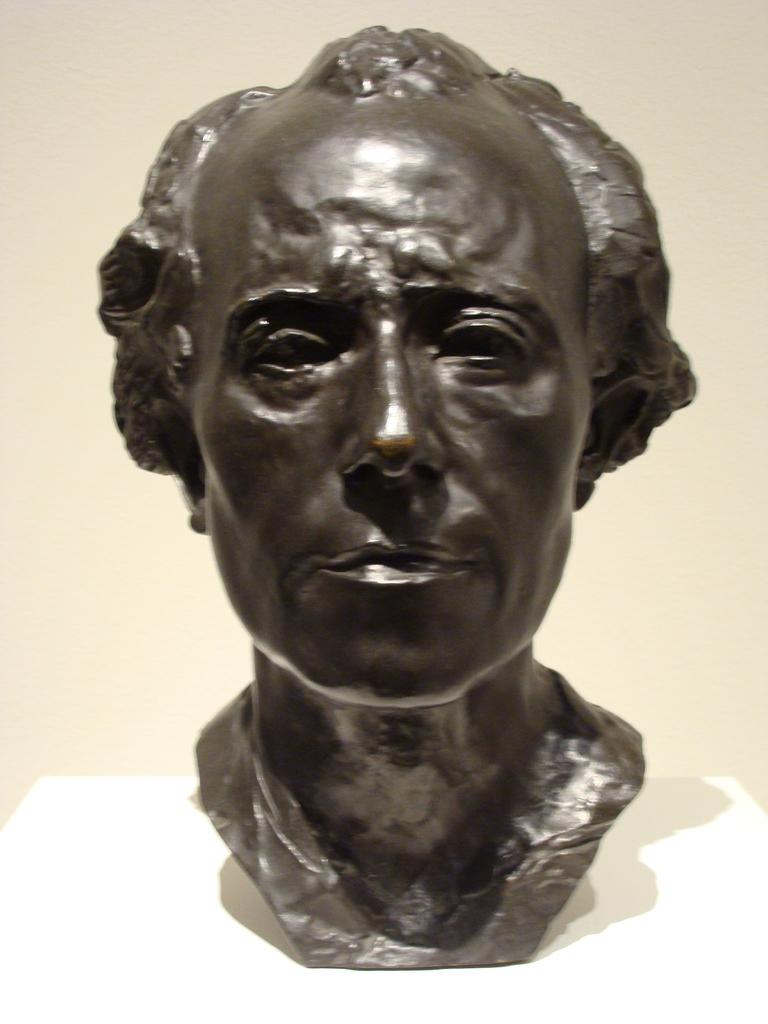What is the main subject of the image? There is a statue in the image. What is the statue a representation of? The statue is of a person's head. What is the statue placed on? The statue is on a white object. How does the statue contribute to the increase in camp attendance? The image does not show any camp or mention any attendance, so it is not possible to determine how the statue might affect camp attendance. 